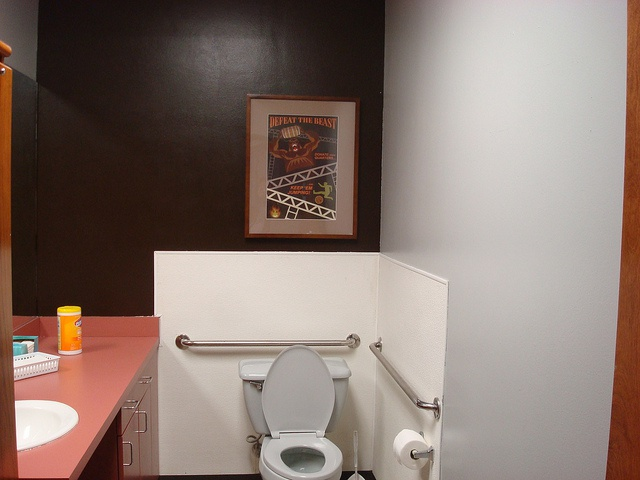Describe the objects in this image and their specific colors. I can see toilet in gray, darkgray, and lightgray tones and sink in gray, white, lightpink, darkgray, and lightgray tones in this image. 